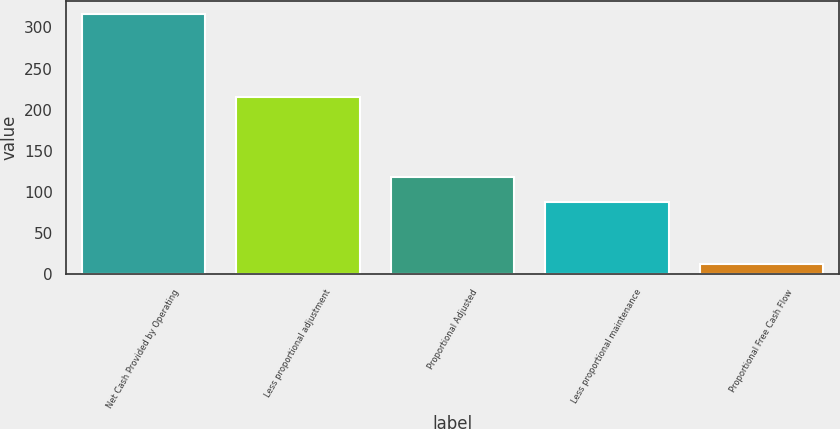<chart> <loc_0><loc_0><loc_500><loc_500><bar_chart><fcel>Net Cash Provided by Operating<fcel>Less proportional adjustment<fcel>Proportional Adjusted<fcel>Less proportional maintenance<fcel>Proportional Free Cash Flow<nl><fcel>316<fcel>215<fcel>118.3<fcel>88<fcel>13<nl></chart> 